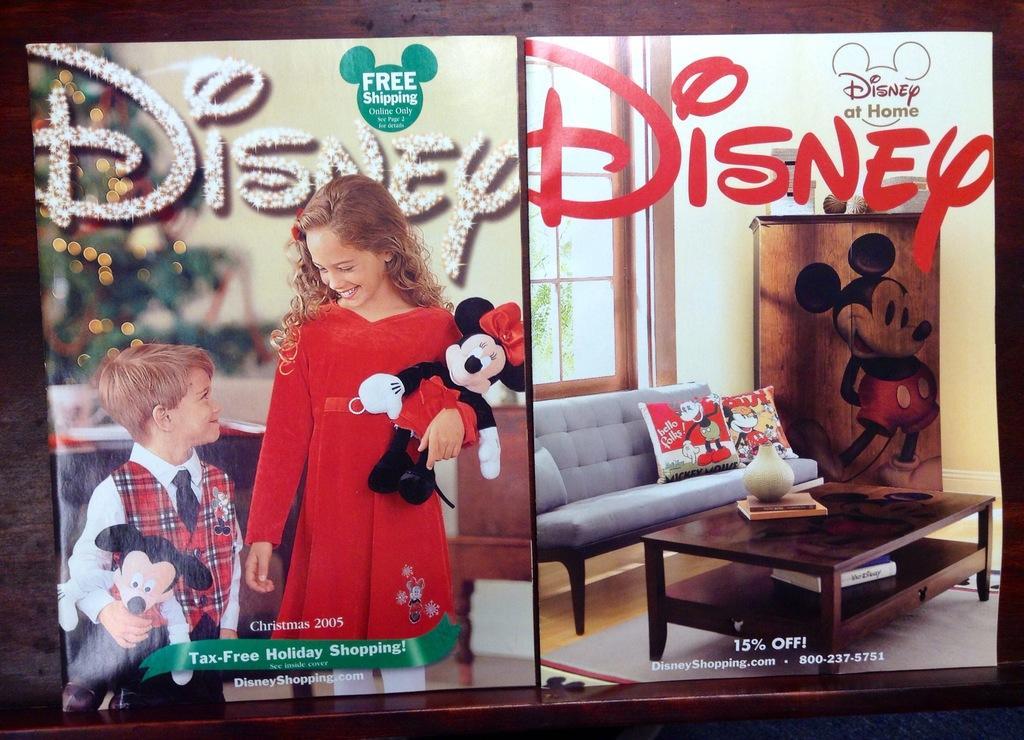In one or two sentences, can you explain what this image depicts? We can able to see 2 posters of Disney. The girl in red dress is holding a toy. This boy is also holding a toy. This is couch with pillows. This is window. This is a cupboard with cartoon picture. On this table there books and flower vase. Floor with carpet. 